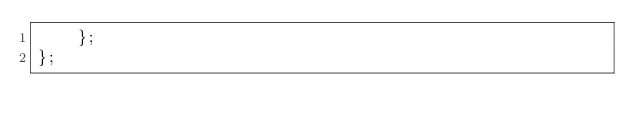Convert code to text. <code><loc_0><loc_0><loc_500><loc_500><_JavaScript_>    };
};
</code> 